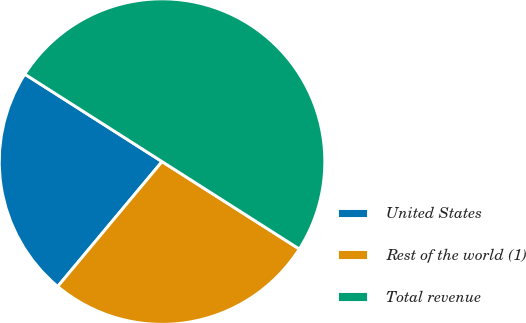Convert chart to OTSL. <chart><loc_0><loc_0><loc_500><loc_500><pie_chart><fcel>United States<fcel>Rest of the world (1)<fcel>Total revenue<nl><fcel>22.95%<fcel>27.05%<fcel>50.0%<nl></chart> 